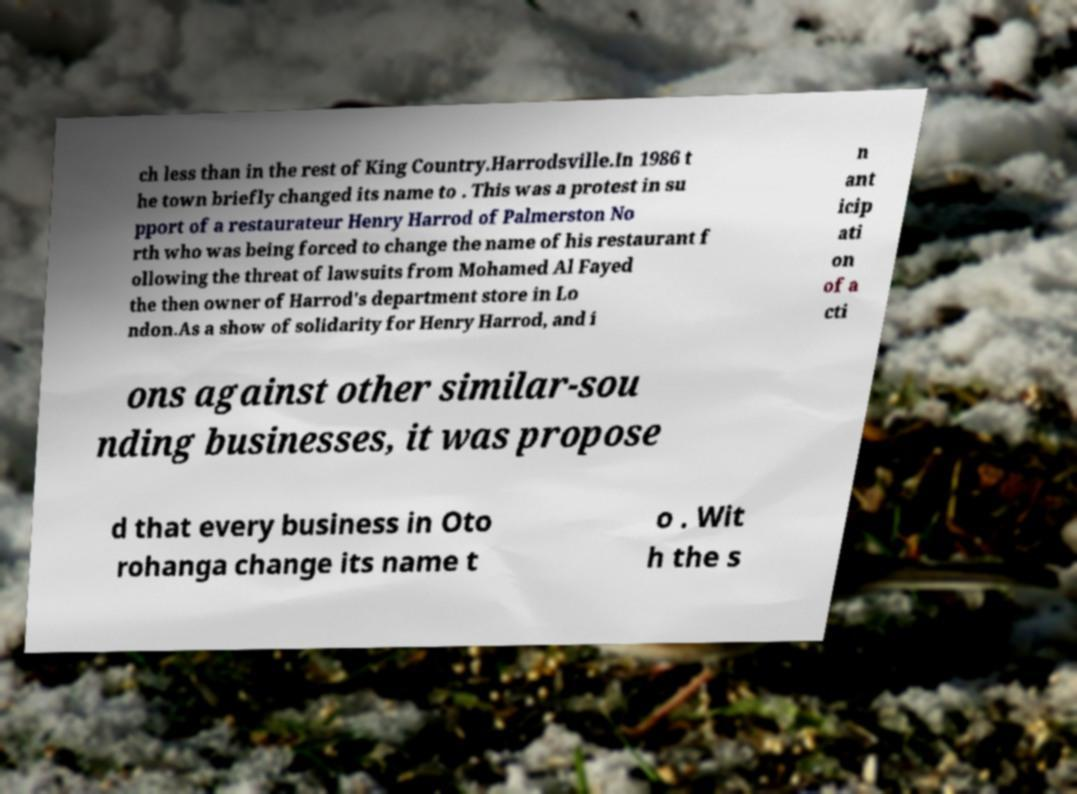Can you accurately transcribe the text from the provided image for me? ch less than in the rest of King Country.Harrodsville.In 1986 t he town briefly changed its name to . This was a protest in su pport of a restaurateur Henry Harrod of Palmerston No rth who was being forced to change the name of his restaurant f ollowing the threat of lawsuits from Mohamed Al Fayed the then owner of Harrod's department store in Lo ndon.As a show of solidarity for Henry Harrod, and i n ant icip ati on of a cti ons against other similar-sou nding businesses, it was propose d that every business in Oto rohanga change its name t o . Wit h the s 